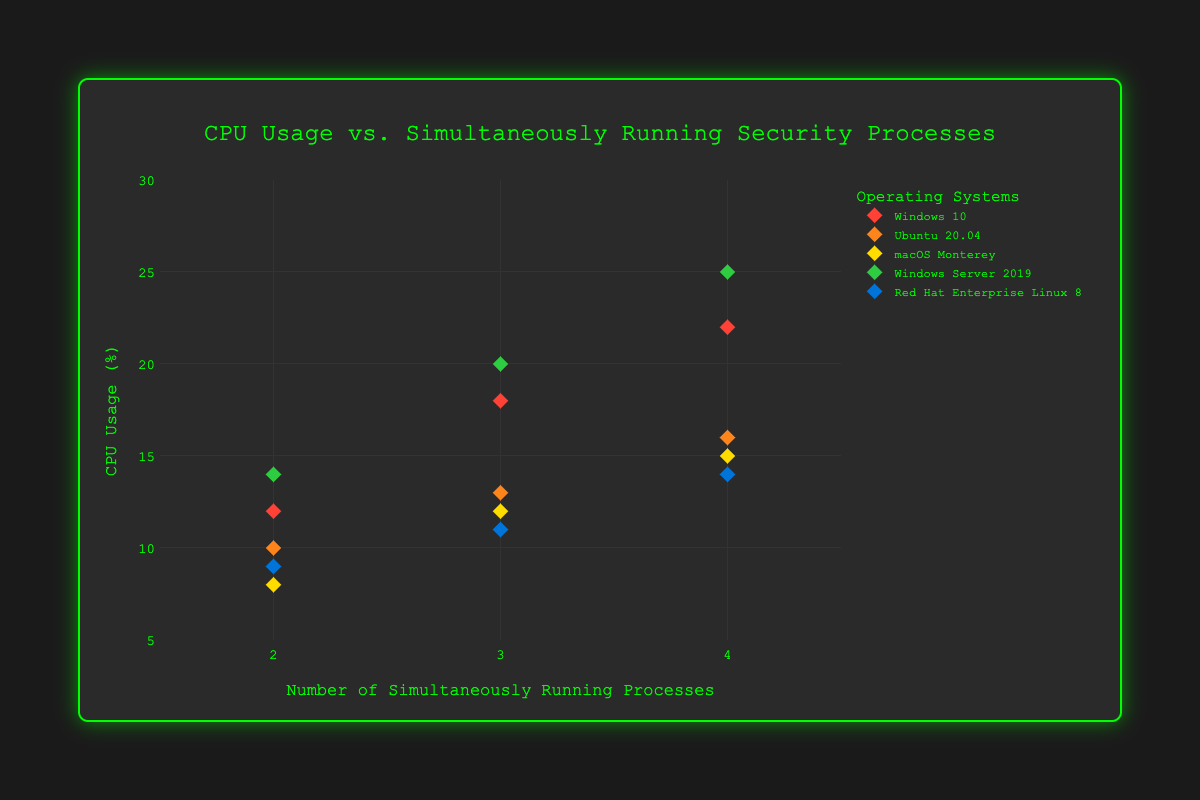What's the title of the figure? The title is displayed prominently at the top of the figure. It provides an overview of what the figure represents.
Answer: CPU Usage vs. Simultaneously Running Security Processes Which operating system has the lowest CPU usage with 4 simultaneously running security processes? Locate the data points corresponding to 4 running processes on the x-axis and check the CPU usage (y-axis). Identify the lowest value and its corresponding operating system.
Answer: Ubuntu 20.04 How does the CPU usage for macOS Monterey change as the number of running processes increases from 2 to 4? Identify the data points for macOS Monterey for 2, 3, and 4 processes. Evaluate the trend in CPU usage values from these points.
Answer: Increases from 8% to 15% Which operating system has the highest CPU usage, and what is the value? Evaluate the highest data point on the y-axis and identify the associated operating system and its CPU usage.
Answer: Windows Server 2019 with 25% What's the average CPU usage for Ubuntu 20.04 across all the number of running processes? Sum the CPU usage values for Ubuntu 20.04 (10%, 13%, and 16%) and divide by the total number of data points (3) for this OS.
Answer: 13% For Windows 10, what's the difference in CPU usage between running 2 processes and 4 processes? Identify the CPU usage values for Windows 10 at 2 and 4 running processes. Calculate the difference between these two values.
Answer: 10% Which operating system experiences a greater increase in CPU usage when moving from 2 to 3 security processes: Windows Server 2019 or Red Hat Enterprise Linux 8? Calculate the increase in CPU usage for both operating systems when the number of security processes increases from 2 to 3. Compare the differences.
Answer: Windows Server 2019 (6%) What is the range of CPU usage percentages for Red Hat Enterprise Linux 8? Identify the minimum (9%) and maximum (14%) CPU usage values for Red Hat Enterprise Linux 8 and calculate the range by subtracting the minimum from the maximum.
Answer: 5% At 3 simultaneously running processes, which operating system has the lowest CPU usage, and what is the value? Identify the data points for 3 running processes. Determine the lowest CPU usage value and the corresponding operating system.
Answer: Red Hat Enterprise Linux 8 with 11% Is there any operating system where no data point shows CPU usage exceeding 20%? Check each operating system's data points for CPU usage values exceeding 20%. Confirm if any operating system has no such values.
Answer: Yes, Ubuntu 20.04, macOS Monterey, Red Hat Enterprise Linux 8 